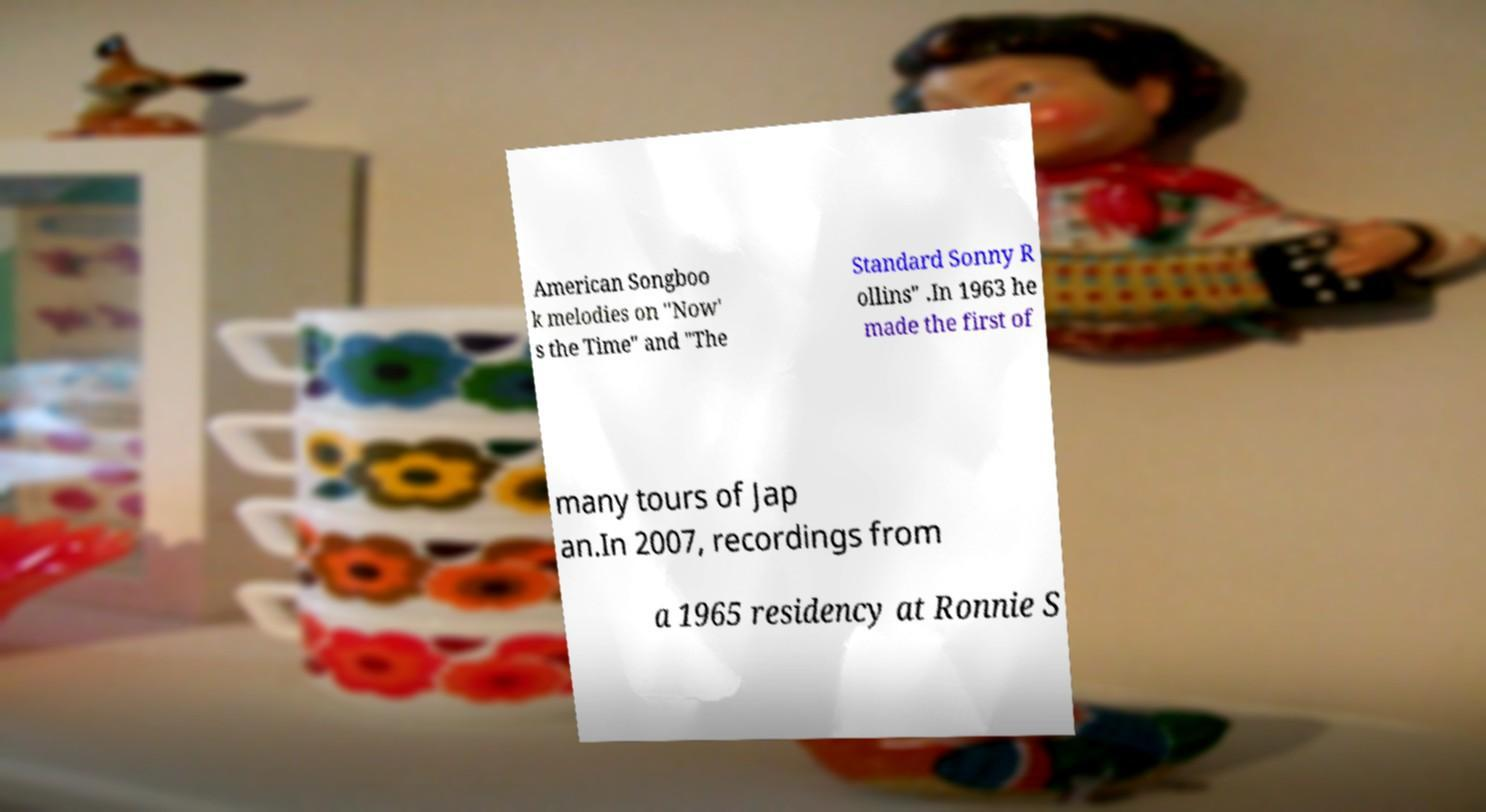What messages or text are displayed in this image? I need them in a readable, typed format. American Songboo k melodies on "Now' s the Time" and "The Standard Sonny R ollins" .In 1963 he made the first of many tours of Jap an.In 2007, recordings from a 1965 residency at Ronnie S 